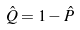Convert formula to latex. <formula><loc_0><loc_0><loc_500><loc_500>\hat { Q } = 1 - \hat { P }</formula> 